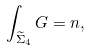Convert formula to latex. <formula><loc_0><loc_0><loc_500><loc_500>\int _ { \widetilde { \Sigma } _ { 4 } } G = n ,</formula> 